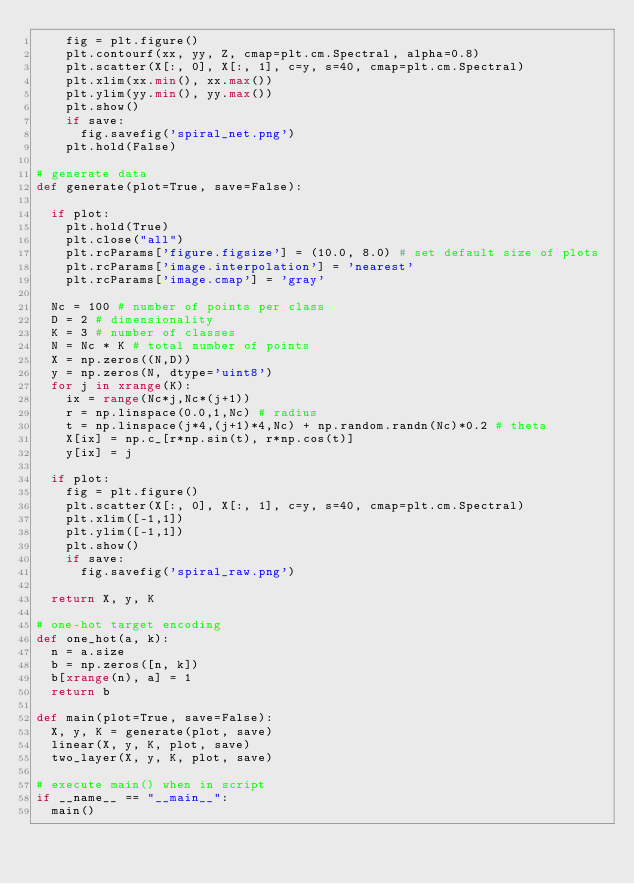<code> <loc_0><loc_0><loc_500><loc_500><_Python_>		fig = plt.figure()
		plt.contourf(xx, yy, Z, cmap=plt.cm.Spectral, alpha=0.8)
		plt.scatter(X[:, 0], X[:, 1], c=y, s=40, cmap=plt.cm.Spectral)
		plt.xlim(xx.min(), xx.max())
		plt.ylim(yy.min(), yy.max())
		plt.show()
		if save:
			fig.savefig('spiral_net.png')
		plt.hold(False)

# generate data
def generate(plot=True, save=False):

	if plot:
		plt.hold(True)
		plt.close("all")
		plt.rcParams['figure.figsize'] = (10.0, 8.0) # set default size of plots
		plt.rcParams['image.interpolation'] = 'nearest'
		plt.rcParams['image.cmap'] = 'gray'

	Nc = 100 # number of points per class
	D = 2 # dimensionality
	K = 3 # number of classes
	N = Nc * K # total number of points
	X = np.zeros((N,D))
	y = np.zeros(N, dtype='uint8')
	for j in xrange(K):
		ix = range(Nc*j,Nc*(j+1))
		r = np.linspace(0.0,1,Nc) # radius
		t = np.linspace(j*4,(j+1)*4,Nc) + np.random.randn(Nc)*0.2 # theta
		X[ix] = np.c_[r*np.sin(t), r*np.cos(t)]
		y[ix] = j

	if plot:
		fig = plt.figure()
		plt.scatter(X[:, 0], X[:, 1], c=y, s=40, cmap=plt.cm.Spectral)
		plt.xlim([-1,1])
		plt.ylim([-1,1])
		plt.show()
		if save:
			fig.savefig('spiral_raw.png')

	return X, y, K

# one-hot target encoding
def one_hot(a, k):
	n = a.size
	b = np.zeros([n, k])
	b[xrange(n), a] = 1
	return b

def main(plot=True, save=False):
	X, y, K = generate(plot, save)
	linear(X, y, K, plot, save)
	two_layer(X, y, K, plot, save)

# execute main() when in script
if __name__ == "__main__":
	main()
</code> 